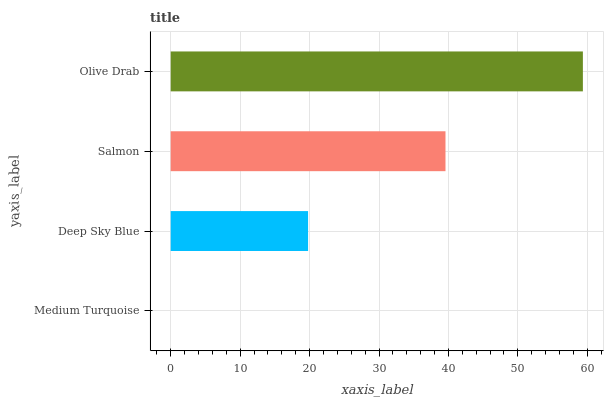Is Medium Turquoise the minimum?
Answer yes or no. Yes. Is Olive Drab the maximum?
Answer yes or no. Yes. Is Deep Sky Blue the minimum?
Answer yes or no. No. Is Deep Sky Blue the maximum?
Answer yes or no. No. Is Deep Sky Blue greater than Medium Turquoise?
Answer yes or no. Yes. Is Medium Turquoise less than Deep Sky Blue?
Answer yes or no. Yes. Is Medium Turquoise greater than Deep Sky Blue?
Answer yes or no. No. Is Deep Sky Blue less than Medium Turquoise?
Answer yes or no. No. Is Salmon the high median?
Answer yes or no. Yes. Is Deep Sky Blue the low median?
Answer yes or no. Yes. Is Medium Turquoise the high median?
Answer yes or no. No. Is Salmon the low median?
Answer yes or no. No. 